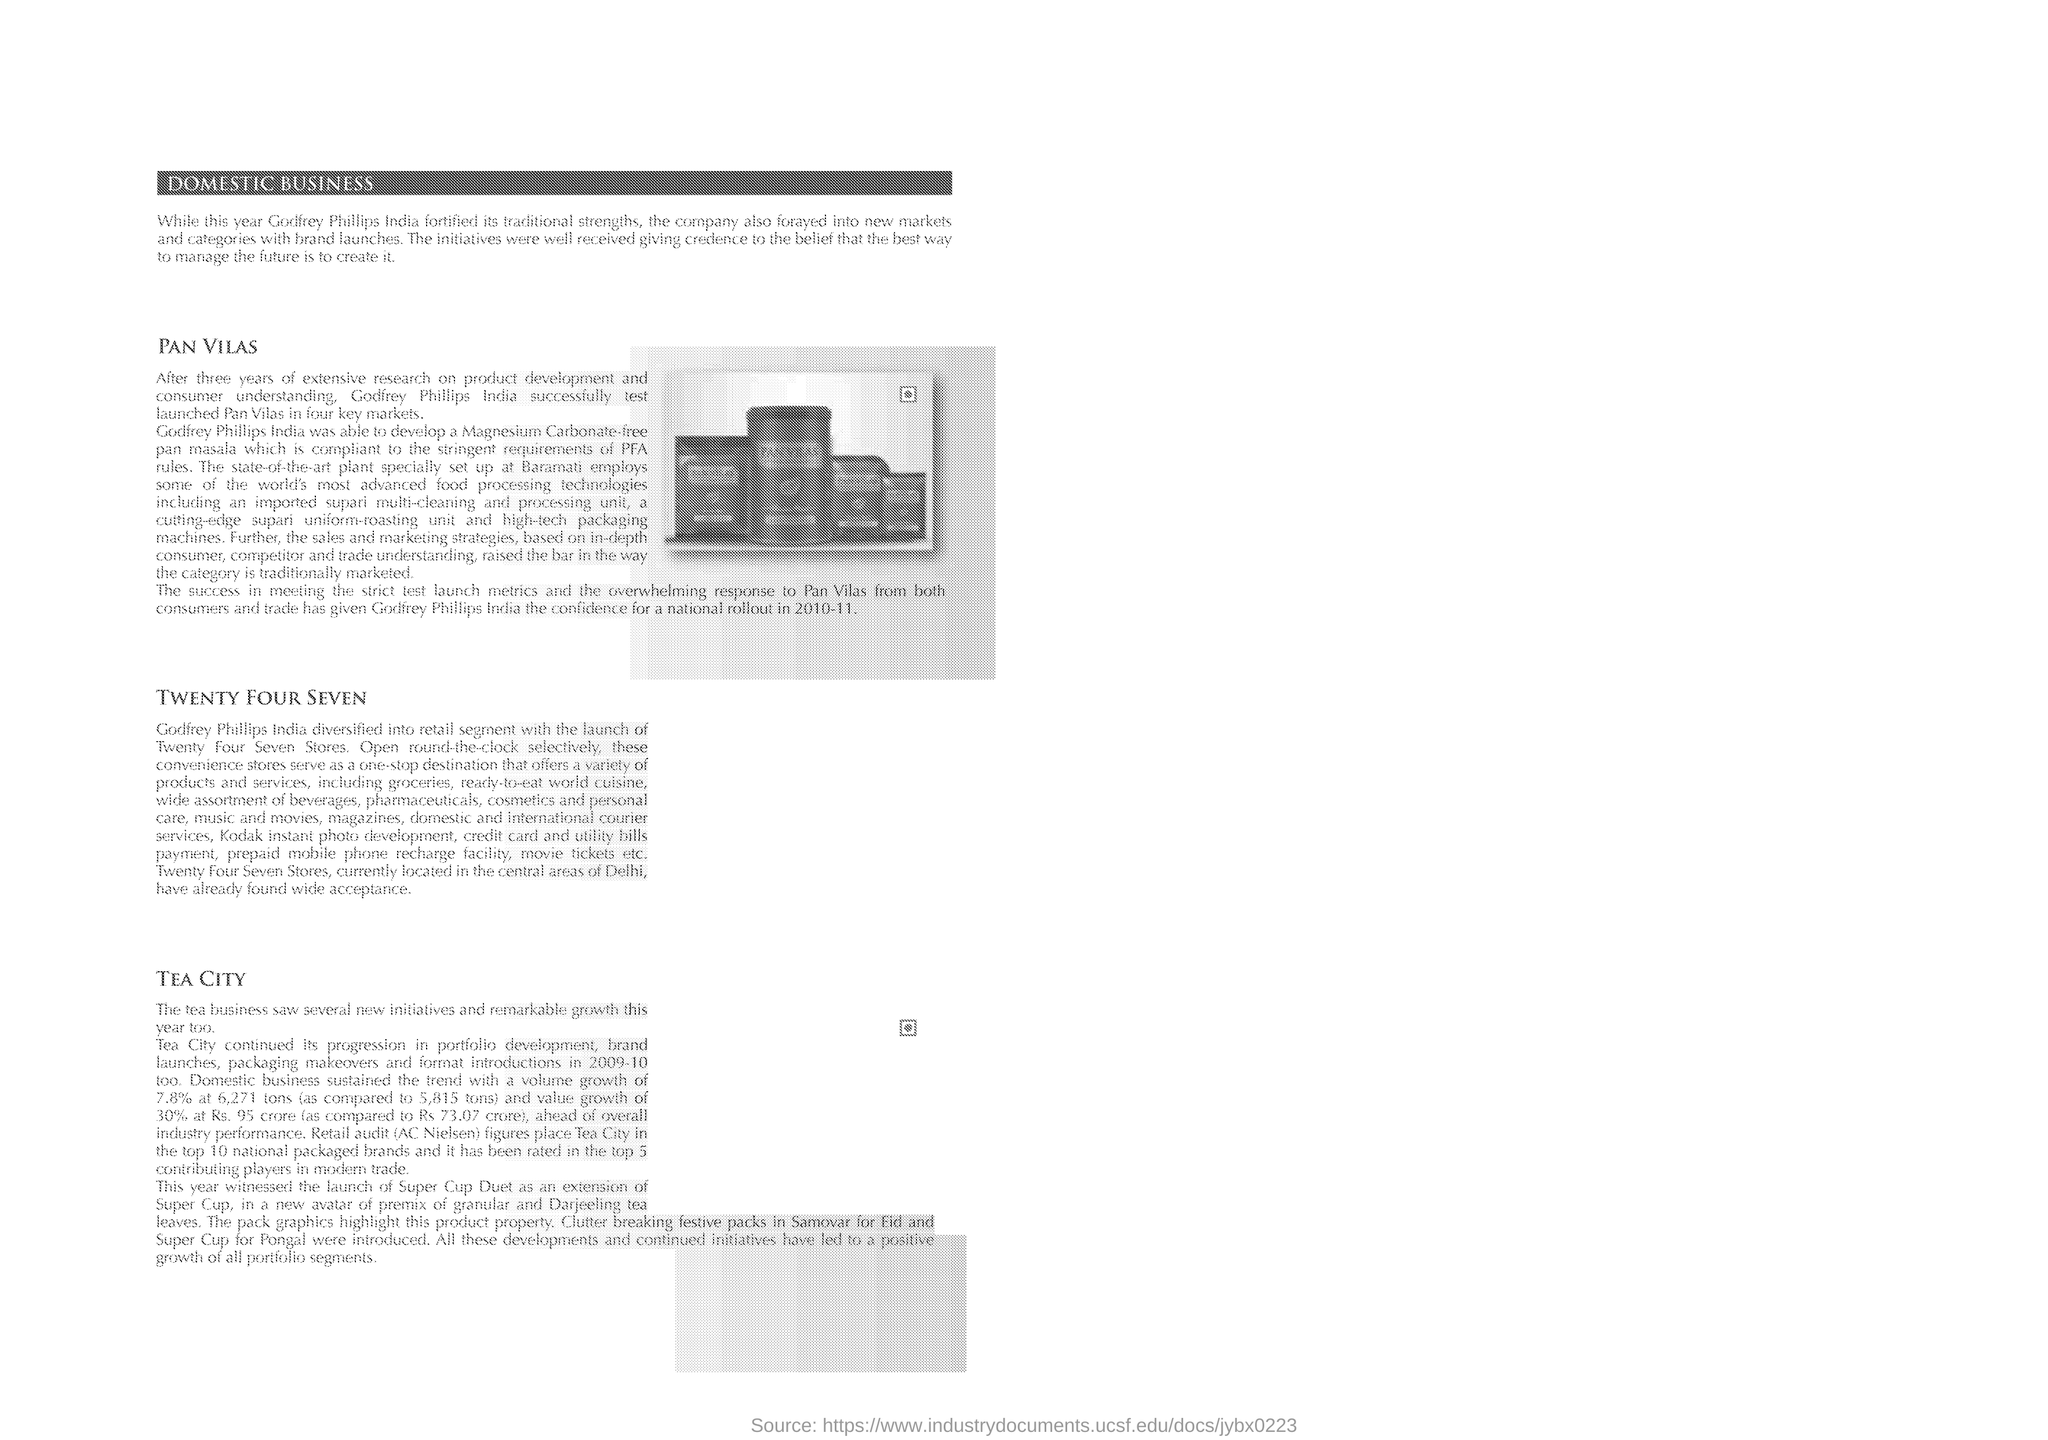Which product was launched in four key markets by Godfrey phillips India after several tests?
Provide a short and direct response. Pan Vilas. In which year, the trade has given Godfrey Phillips India the confidence for a national rollout?
Offer a very short reply. 2010-11. Which was the one-stop destination that offers a variety of products and services?
Provide a short and direct response. Convenience stores. 